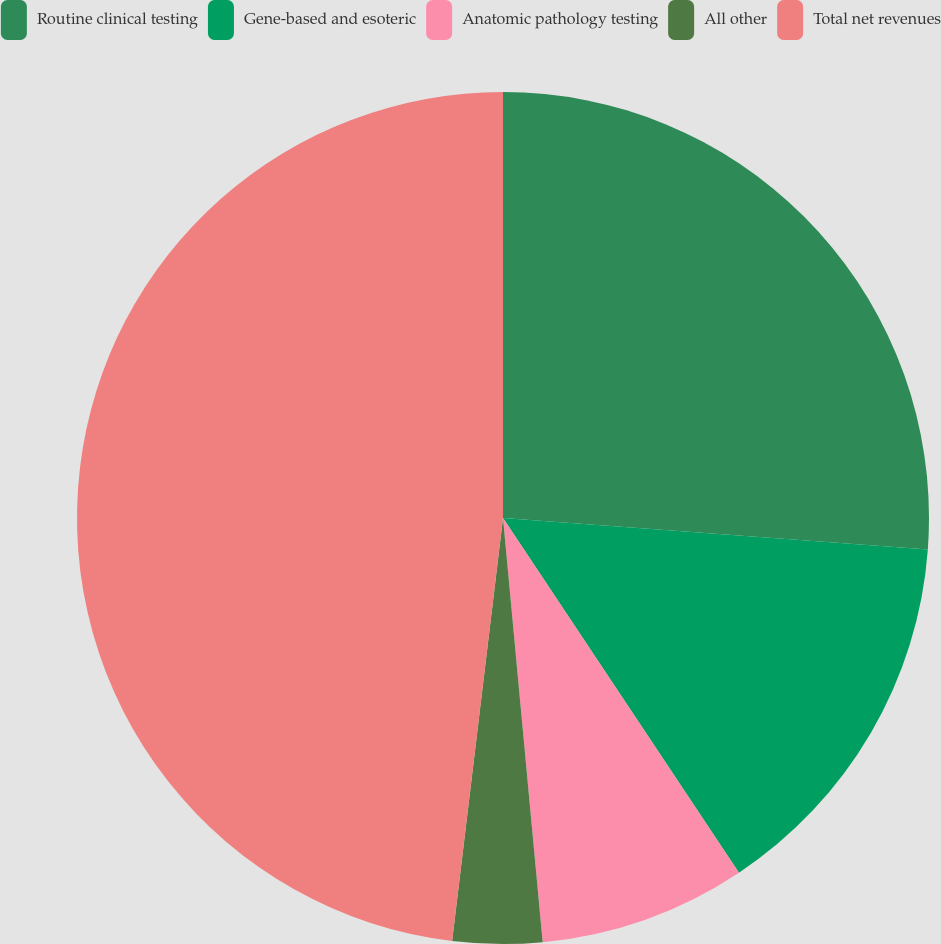Convert chart. <chart><loc_0><loc_0><loc_500><loc_500><pie_chart><fcel>Routine clinical testing<fcel>Gene-based and esoteric<fcel>Anatomic pathology testing<fcel>All other<fcel>Total net revenues<nl><fcel>26.18%<fcel>14.48%<fcel>7.86%<fcel>3.39%<fcel>48.1%<nl></chart> 